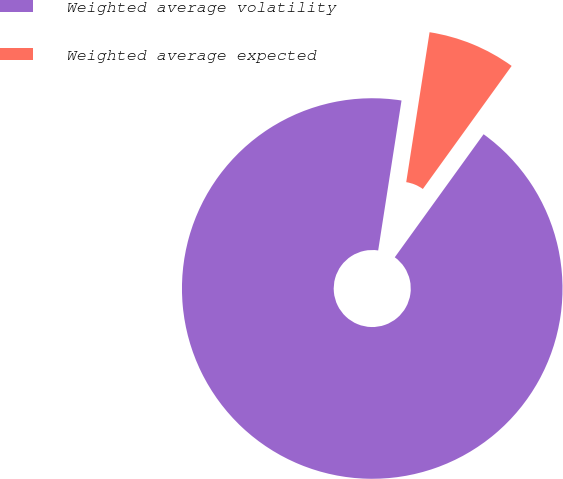Convert chart. <chart><loc_0><loc_0><loc_500><loc_500><pie_chart><fcel>Weighted average volatility<fcel>Weighted average expected<nl><fcel>92.51%<fcel>7.49%<nl></chart> 